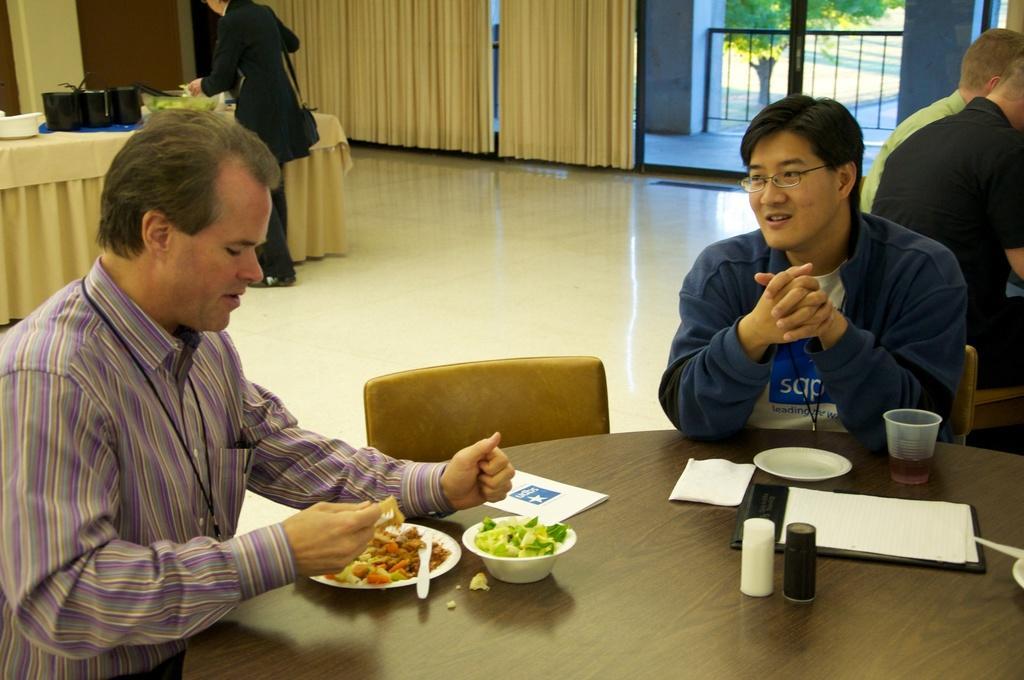Could you give a brief overview of what you see in this image? In this image there are people sitting and we can see a table there are plates, knife, fork, bowls, glass, sprinklers and papers placed on the table. There is a chair. In the background there are curtains and there is a person. On the right there is a gate and we can see things placed on the table. 